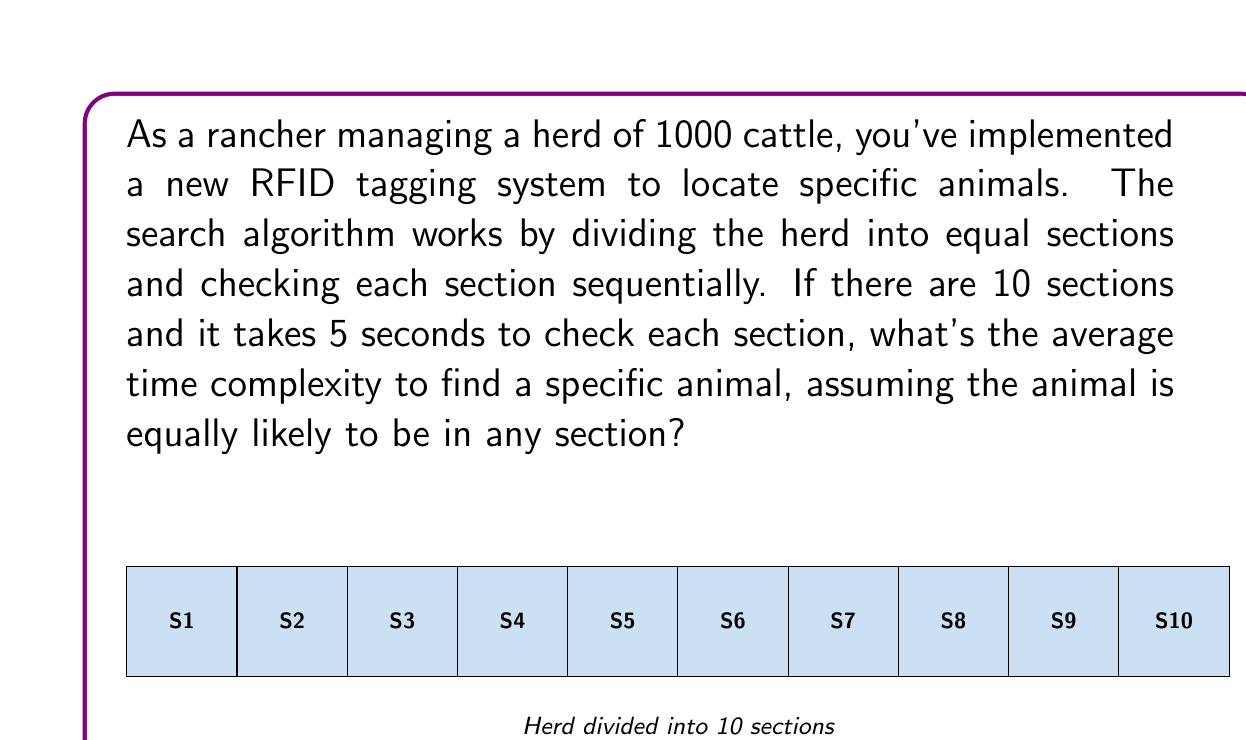Give your solution to this math problem. Let's approach this step-by-step:

1) First, we need to understand what "average time complexity" means in this context. It's the expected number of sections we need to check before finding the animal.

2) Since the animal is equally likely to be in any section, we can use the formula for the expected value of a uniform distribution:

   $E(X) = \frac{n+1}{2}$

   Where $n$ is the number of sections.

3) In this case, $n = 10$, so:

   $E(X) = \frac{10+1}{2} = 5.5$

4) This means, on average, we need to check 5.5 sections.

5) Now, we know it takes 5 seconds to check each section. So to get the average time, we multiply:

   Average time = $5.5 \times 5 = 27.5$ seconds

6) In Big O notation, this is $O(n)$ where $n$ is the number of sections, because in the worst case we might need to check all sections.
Answer: 27.5 seconds, $O(n)$ 